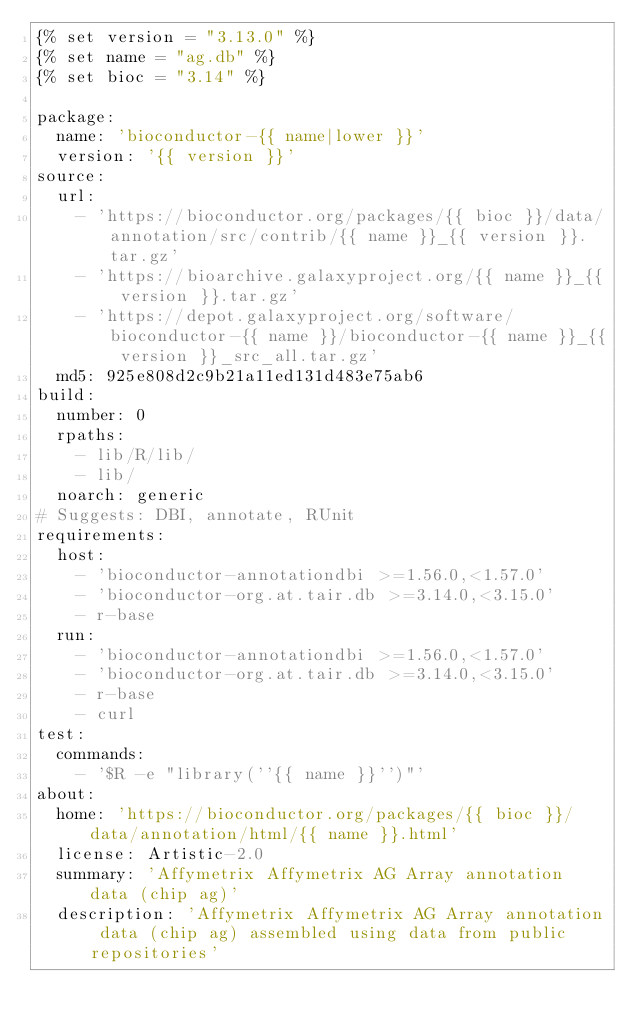Convert code to text. <code><loc_0><loc_0><loc_500><loc_500><_YAML_>{% set version = "3.13.0" %}
{% set name = "ag.db" %}
{% set bioc = "3.14" %}

package:
  name: 'bioconductor-{{ name|lower }}'
  version: '{{ version }}'
source:
  url:
    - 'https://bioconductor.org/packages/{{ bioc }}/data/annotation/src/contrib/{{ name }}_{{ version }}.tar.gz'
    - 'https://bioarchive.galaxyproject.org/{{ name }}_{{ version }}.tar.gz'
    - 'https://depot.galaxyproject.org/software/bioconductor-{{ name }}/bioconductor-{{ name }}_{{ version }}_src_all.tar.gz'
  md5: 925e808d2c9b21a11ed131d483e75ab6
build:
  number: 0
  rpaths:
    - lib/R/lib/
    - lib/
  noarch: generic
# Suggests: DBI, annotate, RUnit
requirements:
  host:
    - 'bioconductor-annotationdbi >=1.56.0,<1.57.0'
    - 'bioconductor-org.at.tair.db >=3.14.0,<3.15.0'
    - r-base
  run:
    - 'bioconductor-annotationdbi >=1.56.0,<1.57.0'
    - 'bioconductor-org.at.tair.db >=3.14.0,<3.15.0'
    - r-base
    - curl
test:
  commands:
    - '$R -e "library(''{{ name }}'')"'
about:
  home: 'https://bioconductor.org/packages/{{ bioc }}/data/annotation/html/{{ name }}.html'
  license: Artistic-2.0
  summary: 'Affymetrix Affymetrix AG Array annotation data (chip ag)'
  description: 'Affymetrix Affymetrix AG Array annotation data (chip ag) assembled using data from public repositories'

</code> 